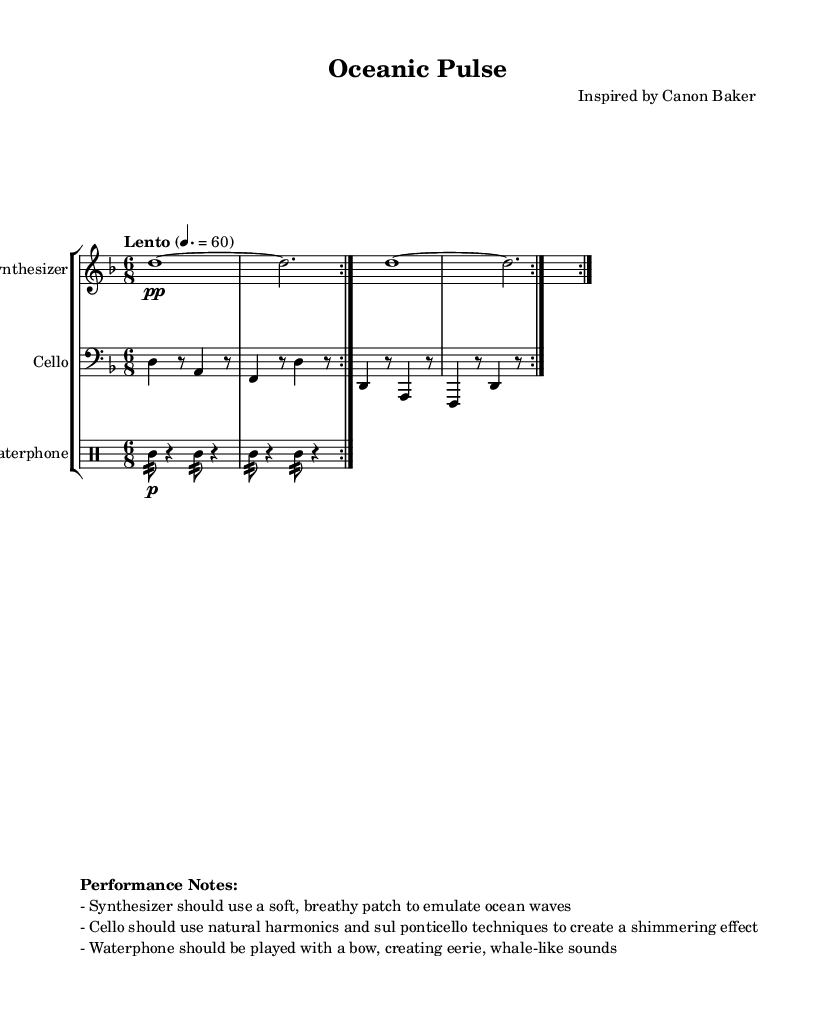What is the key signature of this music? The key signature is indicated at the beginning of the score, showing two flats, which denotes D minor.
Answer: D minor What is the time signature of this piece? The time signature is shown at the beginning of the score with the numbers 6 and 8, indicating that there are six eighth notes in each measure.
Answer: 6/8 What is the tempo marking for this composition? The tempo marking indicates "Lento" alongside a metronome marking of 60, suggesting a slow pace for the piece.
Answer: Lento 60 How many times is the synthesizer part repeated? The repeat volta indication (notated as a "repeat" sign) shows that the synthesizer section is meant to be played twice before moving on.
Answer: 2 What techniques should be used by the cello player? The performance notes detail that the cello should utilize natural harmonics and sul ponticello techniques, creating a specific shimmering sound.
Answer: Natural harmonics and sul ponticello What rhythmic element is emphasized in the waterphone part? The waterphone part primarily consists of the use of "tamb" which indicates a focus on the rhythm of tambourine-like strokes throughout the section.
Answer: Tamb What is the overall thematic influence of this piece? The performance notes indicate that this piece is inspired by the sounds of ocean waves and marine life, suggesting an aquatic theme.
Answer: Ocean waves and marine life 